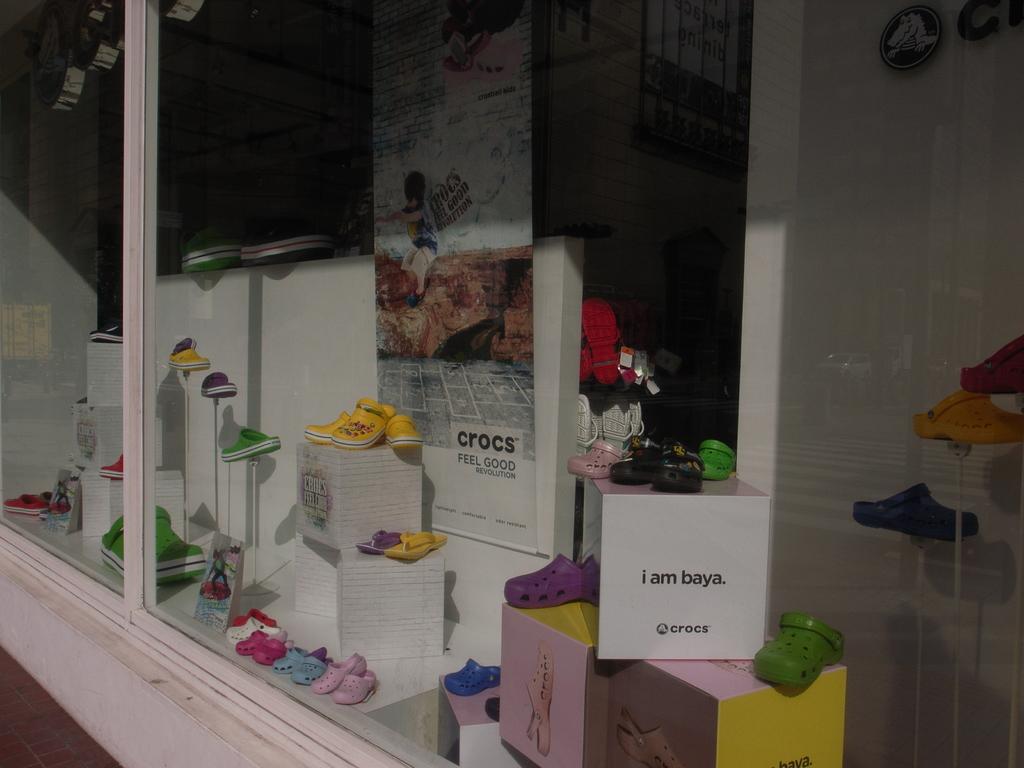What brand of shoes are being displayed?
Provide a succinct answer. Crocs. What does the sign say?
Make the answer very short. I am baya. 